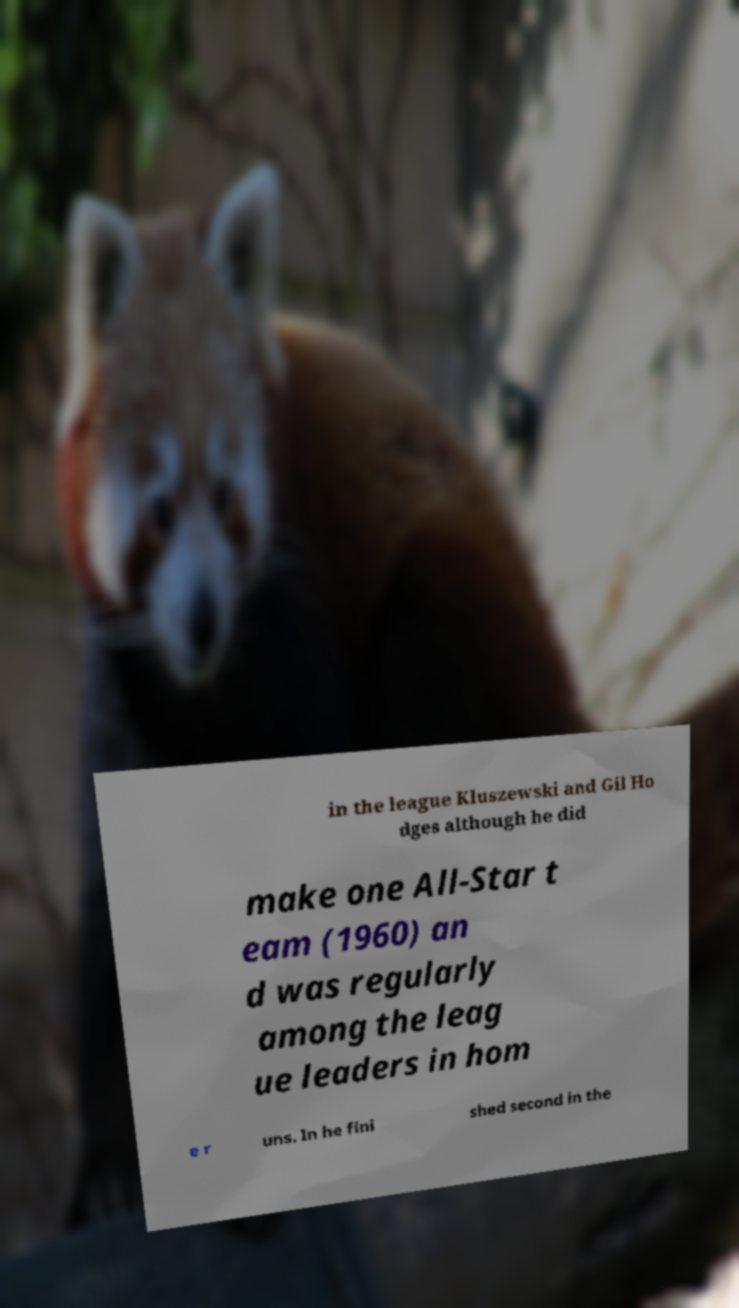Could you extract and type out the text from this image? in the league Kluszewski and Gil Ho dges although he did make one All-Star t eam (1960) an d was regularly among the leag ue leaders in hom e r uns. In he fini shed second in the 